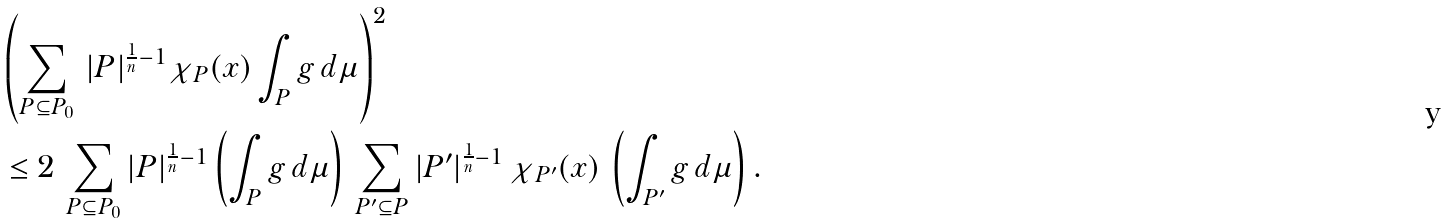Convert formula to latex. <formula><loc_0><loc_0><loc_500><loc_500>& \left ( \sum _ { P \subseteq P _ { 0 } } \, | P | ^ { \frac { 1 } { n } - 1 } \chi _ { P } ( x ) \int _ { P } g \, d \mu \right ) ^ { 2 } \\ & \leq 2 \, \sum _ { P \subseteq P _ { 0 } } | P | ^ { \frac { 1 } { n } - 1 } \left ( \int _ { P } g \, d \mu \right ) \, \sum _ { P ^ { \prime } \subseteq P } | P ^ { \prime } | ^ { \frac { 1 } { n } - 1 } \, \chi _ { P ^ { \prime } } ( x ) \, \left ( \int _ { P ^ { \prime } } g \, d \mu \right ) .</formula> 